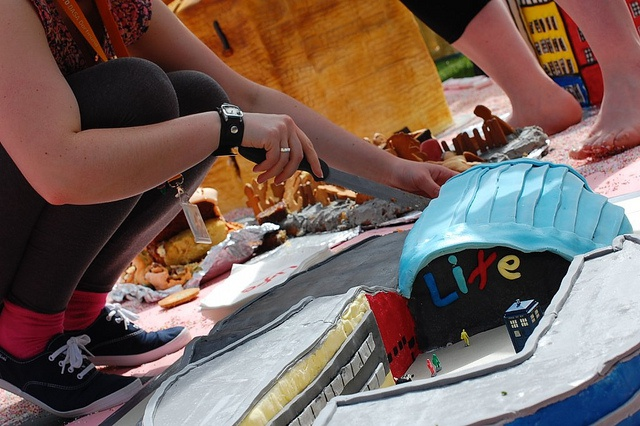Describe the objects in this image and their specific colors. I can see cake in brown, lightgray, gray, black, and lightblue tones, people in brown, black, and maroon tones, people in brown, black, and maroon tones, and knife in brown and black tones in this image. 